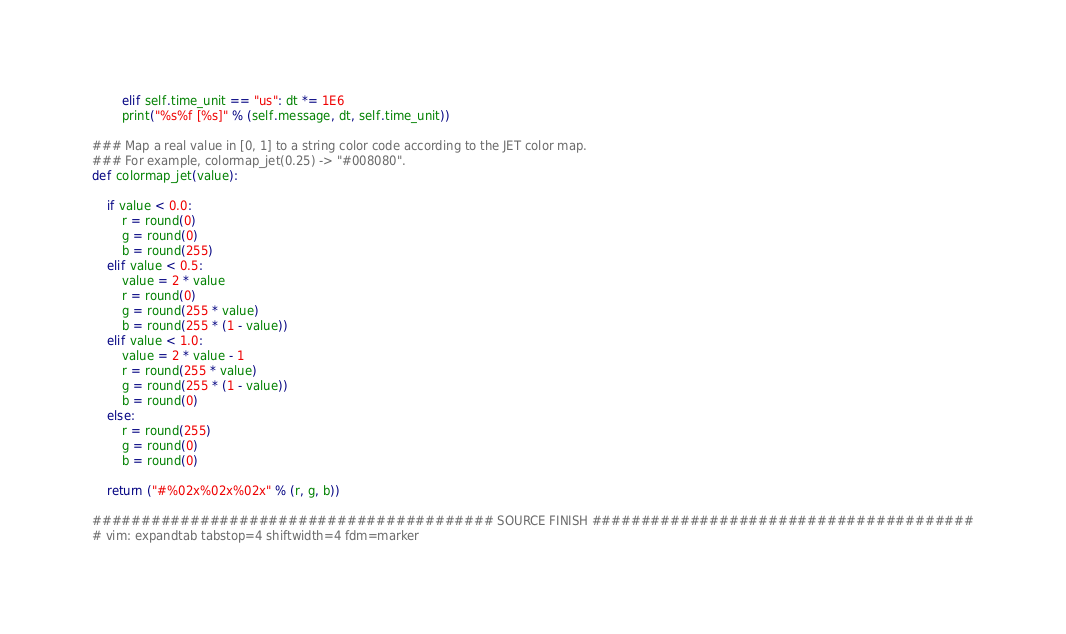Convert code to text. <code><loc_0><loc_0><loc_500><loc_500><_Python_>        elif self.time_unit == "us": dt *= 1E6
        print("%s%f [%s]" % (self.message, dt, self.time_unit))

### Map a real value in [0, 1] to a string color code according to the JET color map.
### For example, colormap_jet(0.25) -> "#008080".
def colormap_jet(value):

    if value < 0.0:
        r = round(0)
        g = round(0)
        b = round(255)
    elif value < 0.5:
        value = 2 * value
        r = round(0)
        g = round(255 * value)
        b = round(255 * (1 - value))
    elif value < 1.0:
        value = 2 * value - 1
        r = round(255 * value)
        g = round(255 * (1 - value))
        b = round(0)
    else:
        r = round(255)
        g = round(0)
        b = round(0)

    return ("#%02x%02x%02x" % (r, g, b))

######################################### SOURCE FINISH #######################################
# vim: expandtab tabstop=4 shiftwidth=4 fdm=marker
</code> 